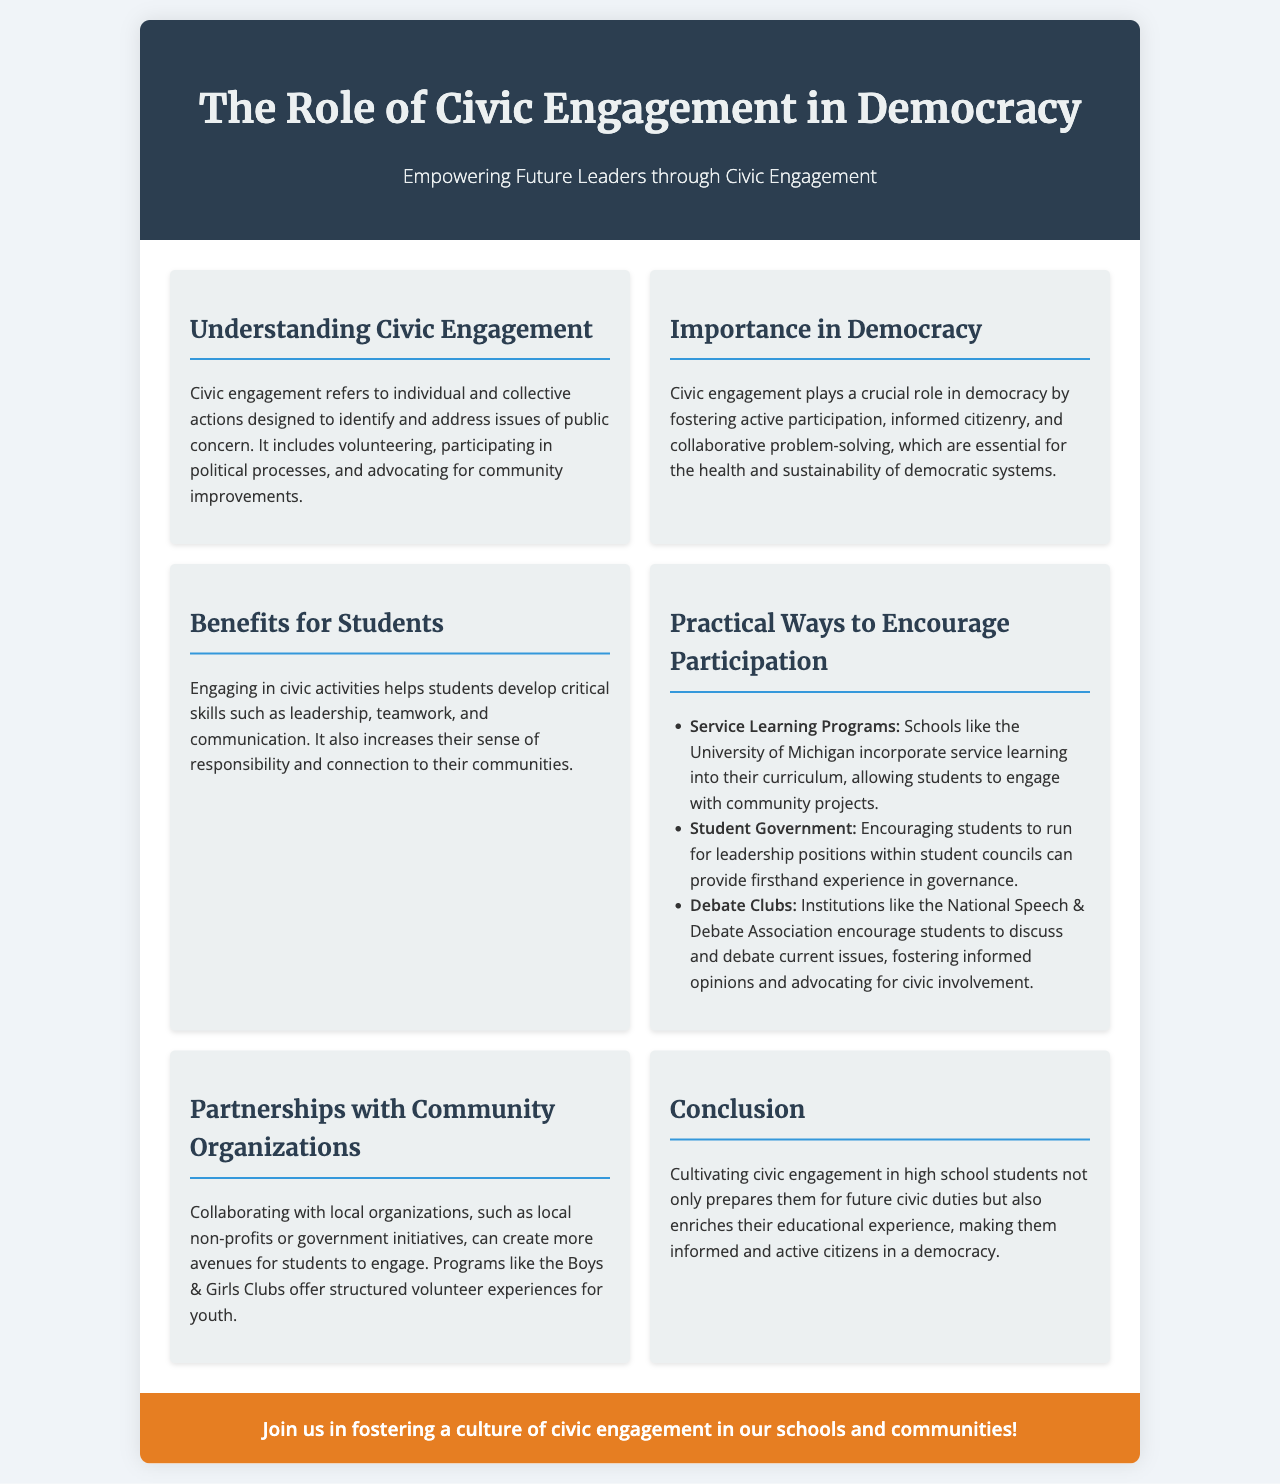What is the title of the brochure? The title is prominently displayed in the header section of the document.
Answer: The Role of Civic Engagement in Democracy What does civic engagement include? The document mentions several examples of civic engagement in the section on understanding civic engagement.
Answer: Volunteering, participating in political processes, and advocating for community improvements Why is civic engagement important in democracy? The document highlights the role of civic engagement in maintaining a healthy democracy in the corresponding section.
Answer: Fostering active participation, informed citizenry, and collaborative problem-solving What is one practical way to encourage participation? The brochure provides multiple methods in the practical ways section.
Answer: Service Learning Programs Which organization encourages debate among students? The document references an organization that promotes debate activities in the practical ways section.
Answer: National Speech & Debate Association What do civic activities help students develop? The benefits section outlines skills that students gain from participating in civic engagement.
Answer: Leadership, teamwork, and communication What do partnerships with community organizations create? The text explains the impact of collaboration with local organizations on student engagement.
Answer: More avenues for students to engage What is the aim of the call to action? The conclusion of the brochure emphasizes the goal of promoting a specific cultural change in schools and communities.
Answer: Fostering a culture of civic engagement in our schools and communities 